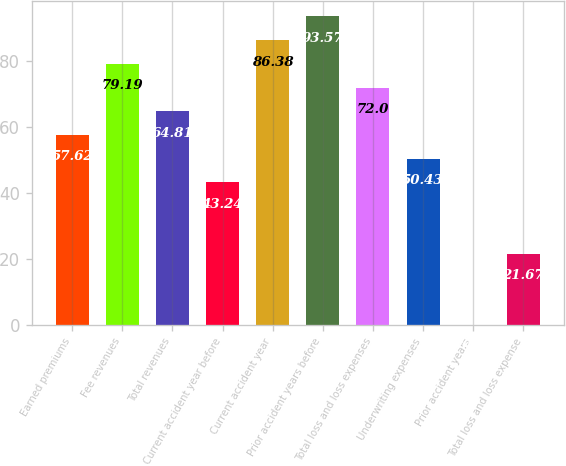Convert chart to OTSL. <chart><loc_0><loc_0><loc_500><loc_500><bar_chart><fcel>Earned premiums<fcel>Fee revenues<fcel>Total revenues<fcel>Current accident year before<fcel>Current accident year<fcel>Prior accident years before<fcel>Total loss and loss expenses<fcel>Underwriting expenses<fcel>Prior accident years<fcel>Total loss and loss expense<nl><fcel>57.62<fcel>79.19<fcel>64.81<fcel>43.24<fcel>86.38<fcel>93.57<fcel>72<fcel>50.43<fcel>0.1<fcel>21.67<nl></chart> 